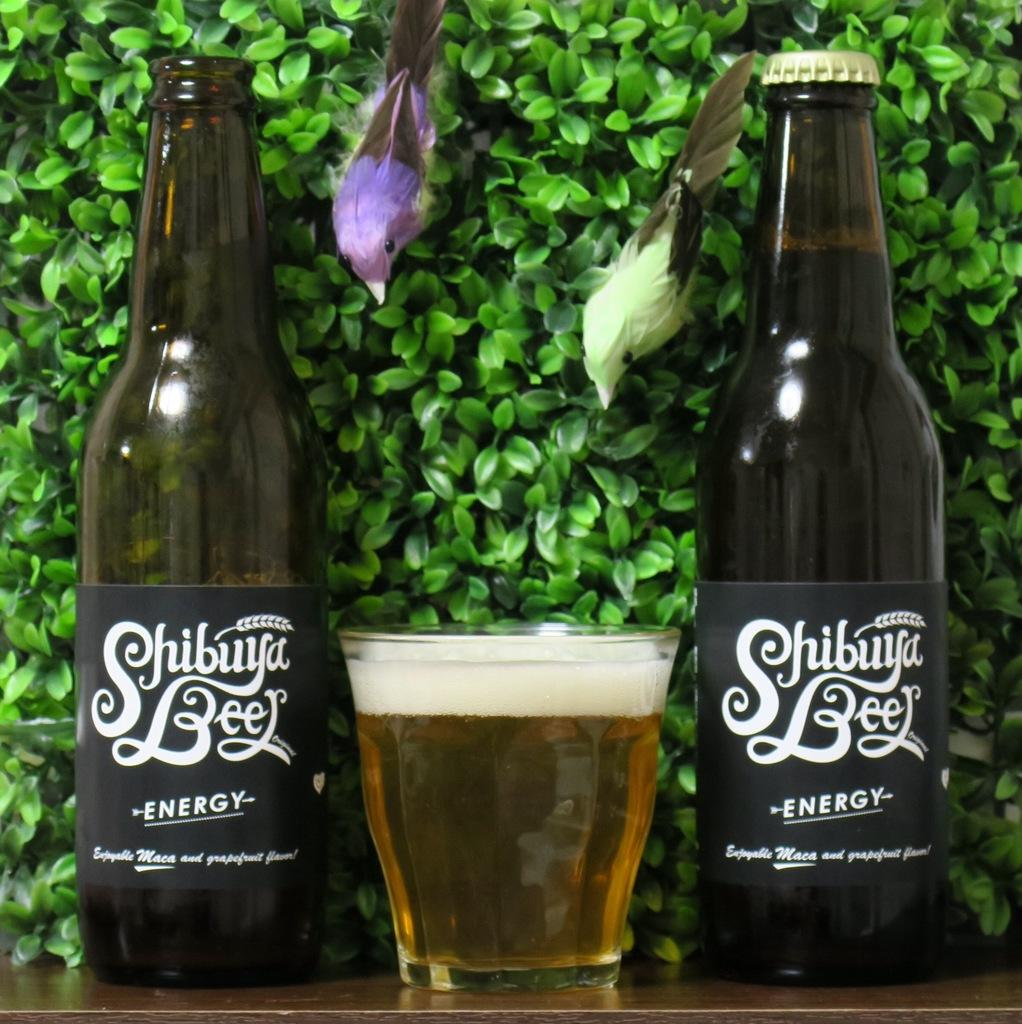<image>
Share a concise interpretation of the image provided. Two Shibuya Energy Beers with a full glass of beer in between the two beers. 